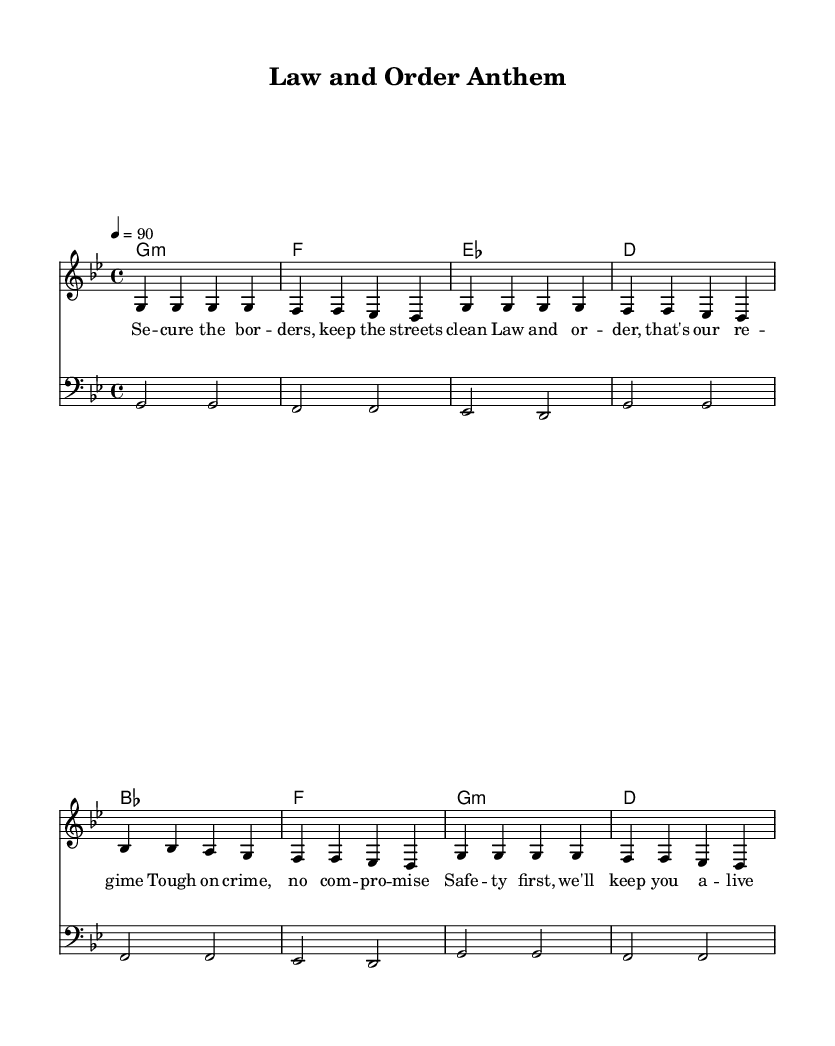What is the key signature of this music? The key signature is G minor, indicated by two flats listed at the beginning of the staff.
Answer: G minor What is the time signature of the piece? The time signature is 4/4, meaning there are four beats in a measure. This is shown at the beginning of the score.
Answer: 4/4 What is the tempo of the music? The tempo is marked at 90 beats per minute, as indicated by "4 = 90" at the start of the score.
Answer: 90 How many times does the phrase "Law and order" appear in the lyrics? The phrase appears twice in the lyrics of the piece, as can be counted in the lyric section.
Answer: 2 Which chord is used at the start of the harmonies? The first chord used in the harmonies is G minor, indicated in the chord mode section at the beginning.
Answer: G minor What is the main theme of the rap lyrics? The main theme revolves around law enforcement and tough-on-crime policies, as highlighted in various phrases throughout the lyrics.
Answer: Law and order Which type of clef is used for the bass staff? The bass staff uses the bass clef, which helps indicate the lower range for the bass notes.
Answer: Bass 